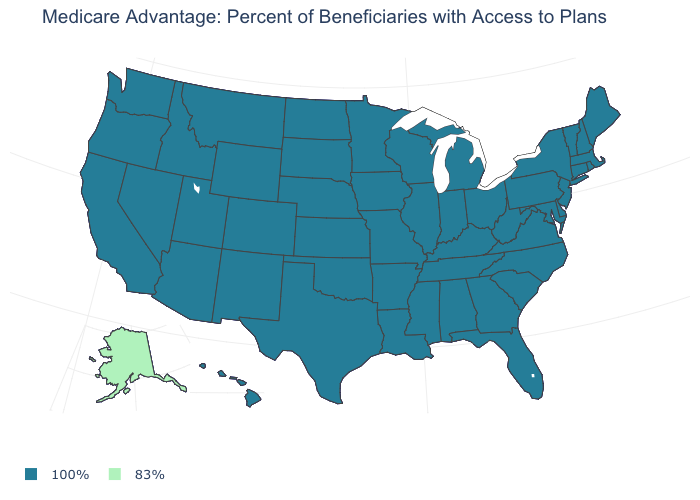Does the map have missing data?
Answer briefly. No. Which states have the highest value in the USA?
Answer briefly. Alabama, Arkansas, Arizona, California, Colorado, Connecticut, Delaware, Florida, Georgia, Hawaii, Iowa, Idaho, Illinois, Indiana, Kansas, Kentucky, Louisiana, Massachusetts, Maryland, Maine, Michigan, Minnesota, Missouri, Mississippi, Montana, North Carolina, North Dakota, Nebraska, New Hampshire, New Jersey, New Mexico, Nevada, New York, Ohio, Oklahoma, Oregon, Pennsylvania, Rhode Island, South Carolina, South Dakota, Tennessee, Texas, Utah, Virginia, Vermont, Washington, Wisconsin, West Virginia, Wyoming. What is the value of Washington?
Be succinct. 100%. What is the highest value in states that border Louisiana?
Quick response, please. 100%. What is the value of Delaware?
Concise answer only. 100%. What is the highest value in the USA?
Keep it brief. 100%. Name the states that have a value in the range 83%?
Short answer required. Alaska. Name the states that have a value in the range 83%?
Be succinct. Alaska. Name the states that have a value in the range 100%?
Give a very brief answer. Alabama, Arkansas, Arizona, California, Colorado, Connecticut, Delaware, Florida, Georgia, Hawaii, Iowa, Idaho, Illinois, Indiana, Kansas, Kentucky, Louisiana, Massachusetts, Maryland, Maine, Michigan, Minnesota, Missouri, Mississippi, Montana, North Carolina, North Dakota, Nebraska, New Hampshire, New Jersey, New Mexico, Nevada, New York, Ohio, Oklahoma, Oregon, Pennsylvania, Rhode Island, South Carolina, South Dakota, Tennessee, Texas, Utah, Virginia, Vermont, Washington, Wisconsin, West Virginia, Wyoming. Is the legend a continuous bar?
Concise answer only. No. Does New Hampshire have the same value as Alaska?
Quick response, please. No. Does Alaska have a higher value than South Carolina?
Give a very brief answer. No. Among the states that border Pennsylvania , which have the highest value?
Keep it brief. Delaware, Maryland, New Jersey, New York, Ohio, West Virginia. What is the value of Nebraska?
Concise answer only. 100%. 